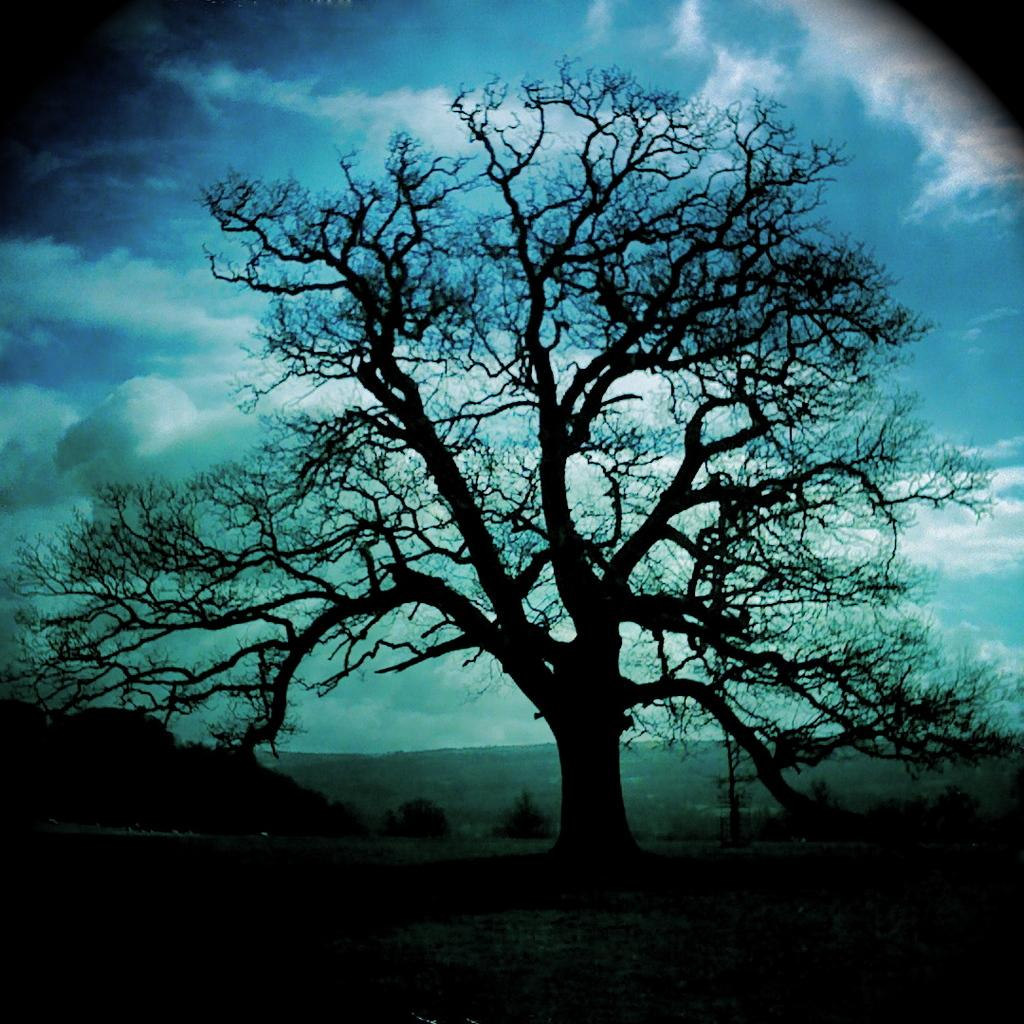What type of natural environment is depicted in the image? There are many trees in the image, suggesting a forest or wooded area. What can be seen in the distance behind the trees? There is farmland visible in the background of the image. What other geographical feature is present in the background? There is a mountain in the background of the image. What is visible at the top of the image? The sky is visible at the top of the image. What can be observed in the sky? Clouds are present in the sky. What type of square is visible in the image? There is no square present in the image. Can you describe the bun that the person in the image is wearing? There is no person or bun visible in the image. 